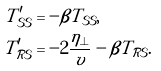<formula> <loc_0><loc_0><loc_500><loc_500>T _ { \mathcal { S S } } ^ { \prime } & = - \beta T _ { \mathcal { S S } } , \\ T _ { \mathcal { R S } } ^ { \prime } & = - 2 \frac { \eta _ { \perp } } { v } - \beta T _ { \mathcal { R S } } .</formula> 